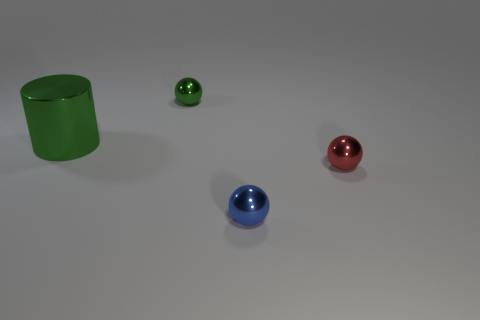Add 3 tiny brown metallic things. How many objects exist? 7 Subtract all cylinders. How many objects are left? 3 Add 1 big purple cylinders. How many big purple cylinders exist? 1 Subtract 0 purple blocks. How many objects are left? 4 Subtract all small blue metallic balls. Subtract all small things. How many objects are left? 0 Add 2 tiny green metallic balls. How many tiny green metallic balls are left? 3 